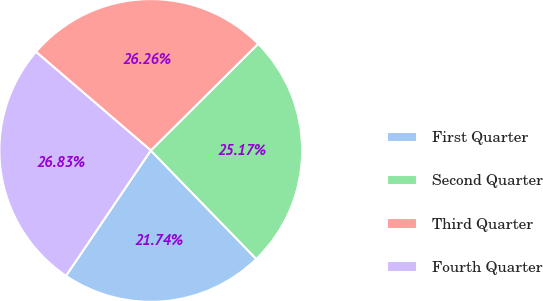Convert chart to OTSL. <chart><loc_0><loc_0><loc_500><loc_500><pie_chart><fcel>First Quarter<fcel>Second Quarter<fcel>Third Quarter<fcel>Fourth Quarter<nl><fcel>21.74%<fcel>25.17%<fcel>26.26%<fcel>26.83%<nl></chart> 